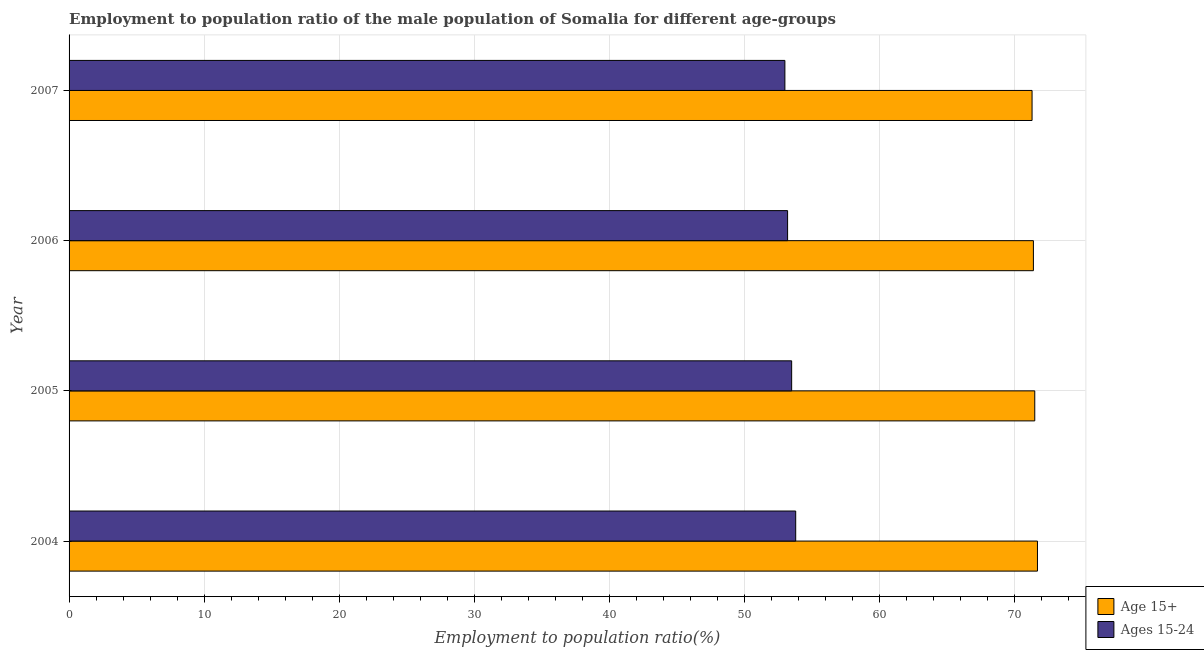How many groups of bars are there?
Ensure brevity in your answer.  4. Are the number of bars on each tick of the Y-axis equal?
Provide a short and direct response. Yes. In how many cases, is the number of bars for a given year not equal to the number of legend labels?
Your answer should be compact. 0. What is the employment to population ratio(age 15-24) in 2006?
Make the answer very short. 53.2. Across all years, what is the maximum employment to population ratio(age 15+)?
Offer a very short reply. 71.7. What is the total employment to population ratio(age 15-24) in the graph?
Ensure brevity in your answer.  213.5. What is the difference between the employment to population ratio(age 15+) in 2006 and the employment to population ratio(age 15-24) in 2005?
Offer a terse response. 17.9. What is the average employment to population ratio(age 15+) per year?
Offer a very short reply. 71.47. In how many years, is the employment to population ratio(age 15+) greater than 40 %?
Provide a short and direct response. 4. What is the ratio of the employment to population ratio(age 15-24) in 2004 to that in 2006?
Your response must be concise. 1.01. Is the employment to population ratio(age 15-24) in 2004 less than that in 2006?
Offer a very short reply. No. What is the difference between the highest and the lowest employment to population ratio(age 15-24)?
Ensure brevity in your answer.  0.8. In how many years, is the employment to population ratio(age 15+) greater than the average employment to population ratio(age 15+) taken over all years?
Your answer should be very brief. 2. What does the 2nd bar from the top in 2006 represents?
Your response must be concise. Age 15+. What does the 2nd bar from the bottom in 2004 represents?
Your answer should be compact. Ages 15-24. How many bars are there?
Provide a short and direct response. 8. Are all the bars in the graph horizontal?
Provide a short and direct response. Yes. How many years are there in the graph?
Offer a very short reply. 4. What is the difference between two consecutive major ticks on the X-axis?
Your answer should be very brief. 10. Where does the legend appear in the graph?
Give a very brief answer. Bottom right. How many legend labels are there?
Your answer should be very brief. 2. What is the title of the graph?
Provide a succinct answer. Employment to population ratio of the male population of Somalia for different age-groups. What is the Employment to population ratio(%) in Age 15+ in 2004?
Keep it short and to the point. 71.7. What is the Employment to population ratio(%) of Ages 15-24 in 2004?
Your response must be concise. 53.8. What is the Employment to population ratio(%) of Age 15+ in 2005?
Offer a very short reply. 71.5. What is the Employment to population ratio(%) of Ages 15-24 in 2005?
Give a very brief answer. 53.5. What is the Employment to population ratio(%) in Age 15+ in 2006?
Keep it short and to the point. 71.4. What is the Employment to population ratio(%) of Ages 15-24 in 2006?
Keep it short and to the point. 53.2. What is the Employment to population ratio(%) in Age 15+ in 2007?
Keep it short and to the point. 71.3. Across all years, what is the maximum Employment to population ratio(%) in Age 15+?
Provide a succinct answer. 71.7. Across all years, what is the maximum Employment to population ratio(%) in Ages 15-24?
Give a very brief answer. 53.8. Across all years, what is the minimum Employment to population ratio(%) of Age 15+?
Provide a succinct answer. 71.3. Across all years, what is the minimum Employment to population ratio(%) in Ages 15-24?
Offer a terse response. 53. What is the total Employment to population ratio(%) of Age 15+ in the graph?
Keep it short and to the point. 285.9. What is the total Employment to population ratio(%) of Ages 15-24 in the graph?
Give a very brief answer. 213.5. What is the difference between the Employment to population ratio(%) in Age 15+ in 2004 and that in 2005?
Provide a short and direct response. 0.2. What is the difference between the Employment to population ratio(%) in Ages 15-24 in 2004 and that in 2005?
Make the answer very short. 0.3. What is the difference between the Employment to population ratio(%) of Ages 15-24 in 2004 and that in 2007?
Provide a succinct answer. 0.8. What is the difference between the Employment to population ratio(%) of Age 15+ in 2005 and that in 2006?
Your answer should be very brief. 0.1. What is the difference between the Employment to population ratio(%) in Age 15+ in 2005 and that in 2007?
Give a very brief answer. 0.2. What is the difference between the Employment to population ratio(%) of Ages 15-24 in 2005 and that in 2007?
Your answer should be very brief. 0.5. What is the difference between the Employment to population ratio(%) of Ages 15-24 in 2006 and that in 2007?
Offer a very short reply. 0.2. What is the difference between the Employment to population ratio(%) in Age 15+ in 2004 and the Employment to population ratio(%) in Ages 15-24 in 2006?
Offer a very short reply. 18.5. What is the difference between the Employment to population ratio(%) in Age 15+ in 2005 and the Employment to population ratio(%) in Ages 15-24 in 2007?
Offer a terse response. 18.5. What is the average Employment to population ratio(%) in Age 15+ per year?
Provide a short and direct response. 71.47. What is the average Employment to population ratio(%) in Ages 15-24 per year?
Your answer should be compact. 53.38. In the year 2004, what is the difference between the Employment to population ratio(%) of Age 15+ and Employment to population ratio(%) of Ages 15-24?
Your answer should be very brief. 17.9. What is the ratio of the Employment to population ratio(%) of Age 15+ in 2004 to that in 2005?
Give a very brief answer. 1. What is the ratio of the Employment to population ratio(%) of Ages 15-24 in 2004 to that in 2005?
Ensure brevity in your answer.  1.01. What is the ratio of the Employment to population ratio(%) in Ages 15-24 in 2004 to that in 2006?
Offer a very short reply. 1.01. What is the ratio of the Employment to population ratio(%) in Age 15+ in 2004 to that in 2007?
Provide a short and direct response. 1.01. What is the ratio of the Employment to population ratio(%) in Ages 15-24 in 2004 to that in 2007?
Ensure brevity in your answer.  1.02. What is the ratio of the Employment to population ratio(%) of Age 15+ in 2005 to that in 2006?
Keep it short and to the point. 1. What is the ratio of the Employment to population ratio(%) of Ages 15-24 in 2005 to that in 2006?
Ensure brevity in your answer.  1.01. What is the ratio of the Employment to population ratio(%) of Ages 15-24 in 2005 to that in 2007?
Offer a terse response. 1.01. What is the ratio of the Employment to population ratio(%) of Age 15+ in 2006 to that in 2007?
Ensure brevity in your answer.  1. What is the difference between the highest and the lowest Employment to population ratio(%) of Ages 15-24?
Offer a terse response. 0.8. 